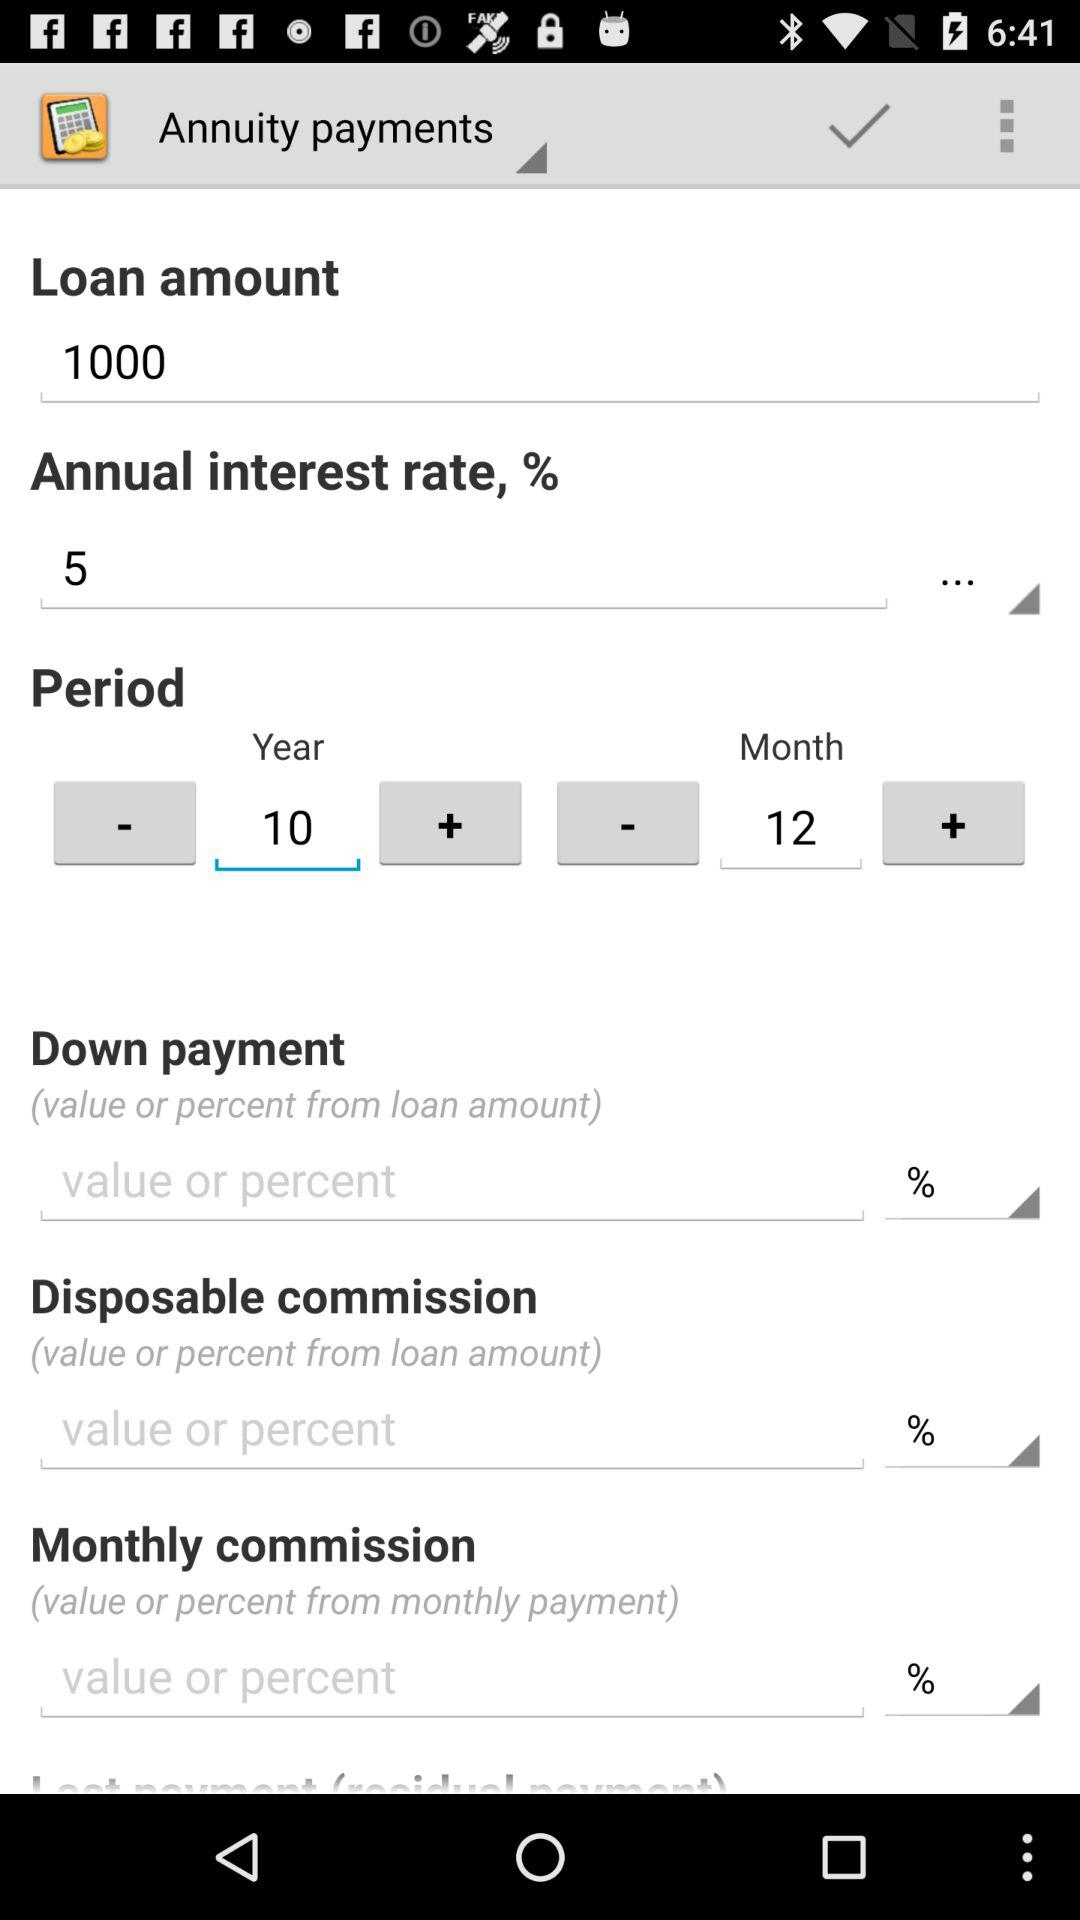What is the time period? The time period is 10 years 12 months. 